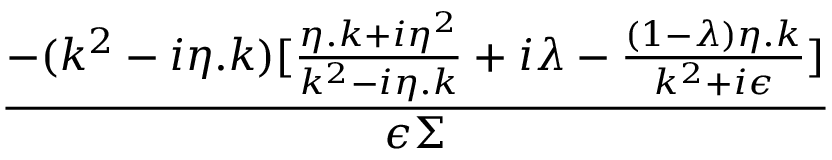Convert formula to latex. <formula><loc_0><loc_0><loc_500><loc_500>\frac { - ( k ^ { 2 } - i \eta . k ) [ \frac { \eta . k + i \eta ^ { 2 } } { k ^ { 2 } - i \eta . k } + i \lambda - \frac { ( 1 - \lambda ) \eta . k } { k ^ { 2 } + i \epsilon } ] } { \epsilon \Sigma }</formula> 